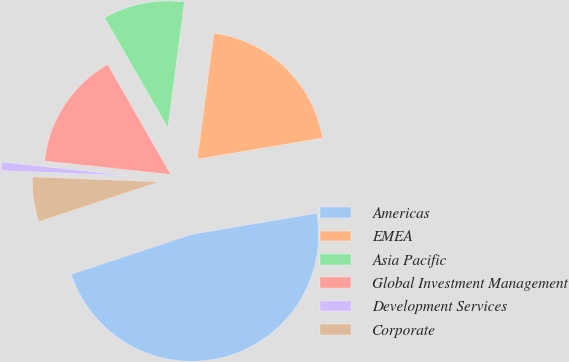<chart> <loc_0><loc_0><loc_500><loc_500><pie_chart><fcel>Americas<fcel>EMEA<fcel>Asia Pacific<fcel>Global Investment Management<fcel>Development Services<fcel>Corporate<nl><fcel>47.56%<fcel>20.27%<fcel>10.37%<fcel>15.02%<fcel>1.07%<fcel>5.72%<nl></chart> 